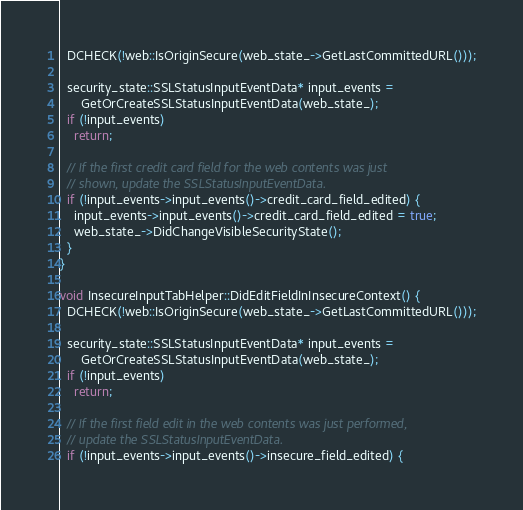Convert code to text. <code><loc_0><loc_0><loc_500><loc_500><_ObjectiveC_>  DCHECK(!web::IsOriginSecure(web_state_->GetLastCommittedURL()));

  security_state::SSLStatusInputEventData* input_events =
      GetOrCreateSSLStatusInputEventData(web_state_);
  if (!input_events)
    return;

  // If the first credit card field for the web contents was just
  // shown, update the SSLStatusInputEventData.
  if (!input_events->input_events()->credit_card_field_edited) {
    input_events->input_events()->credit_card_field_edited = true;
    web_state_->DidChangeVisibleSecurityState();
  }
}

void InsecureInputTabHelper::DidEditFieldInInsecureContext() {
  DCHECK(!web::IsOriginSecure(web_state_->GetLastCommittedURL()));

  security_state::SSLStatusInputEventData* input_events =
      GetOrCreateSSLStatusInputEventData(web_state_);
  if (!input_events)
    return;

  // If the first field edit in the web contents was just performed,
  // update the SSLStatusInputEventData.
  if (!input_events->input_events()->insecure_field_edited) {</code> 